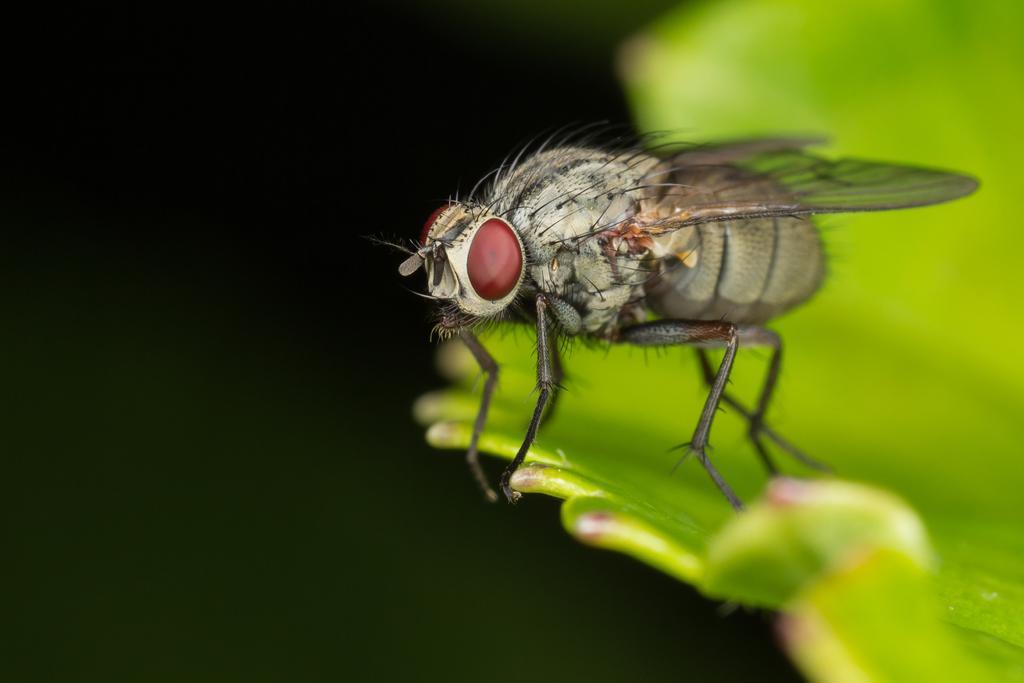Please provide a concise description of this image. In this picture we can see brown color bee with red color eye is sitting on the green color leaf seen in the image. 